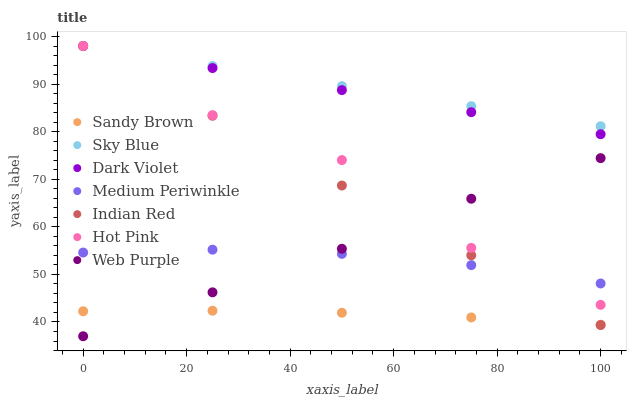Does Sandy Brown have the minimum area under the curve?
Answer yes or no. Yes. Does Sky Blue have the maximum area under the curve?
Answer yes or no. Yes. Does Medium Periwinkle have the minimum area under the curve?
Answer yes or no. No. Does Medium Periwinkle have the maximum area under the curve?
Answer yes or no. No. Is Indian Red the smoothest?
Answer yes or no. Yes. Is Hot Pink the roughest?
Answer yes or no. Yes. Is Medium Periwinkle the smoothest?
Answer yes or no. No. Is Medium Periwinkle the roughest?
Answer yes or no. No. Does Web Purple have the lowest value?
Answer yes or no. Yes. Does Medium Periwinkle have the lowest value?
Answer yes or no. No. Does Sky Blue have the highest value?
Answer yes or no. Yes. Does Medium Periwinkle have the highest value?
Answer yes or no. No. Is Sandy Brown less than Sky Blue?
Answer yes or no. Yes. Is Hot Pink greater than Sandy Brown?
Answer yes or no. Yes. Does Web Purple intersect Indian Red?
Answer yes or no. Yes. Is Web Purple less than Indian Red?
Answer yes or no. No. Is Web Purple greater than Indian Red?
Answer yes or no. No. Does Sandy Brown intersect Sky Blue?
Answer yes or no. No. 